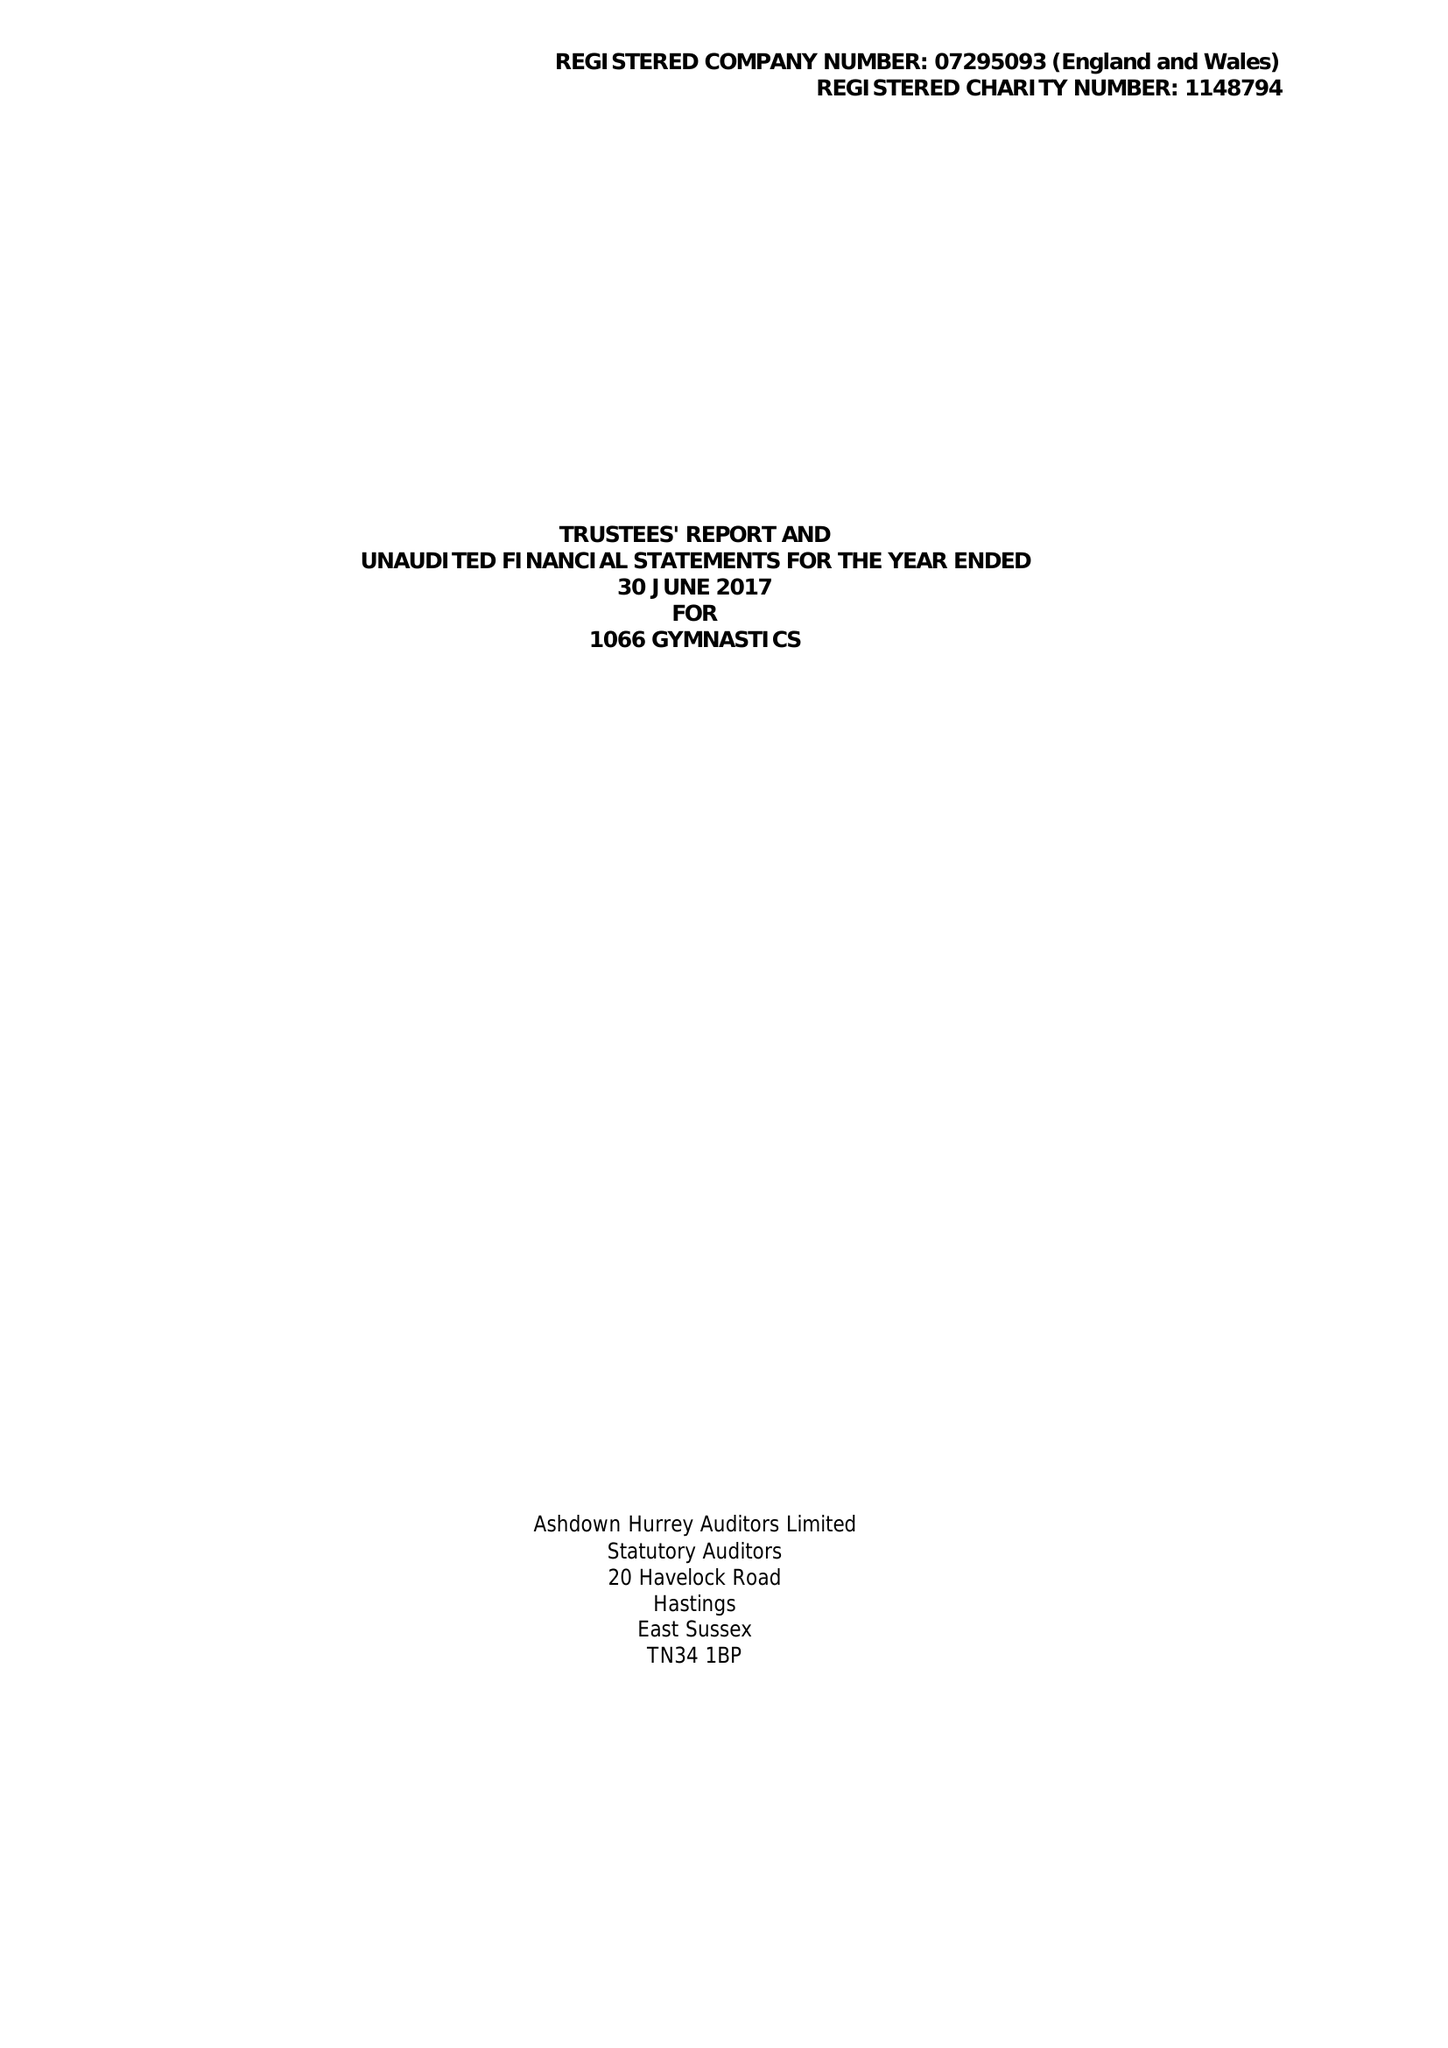What is the value for the spending_annually_in_british_pounds?
Answer the question using a single word or phrase. 341990.00 